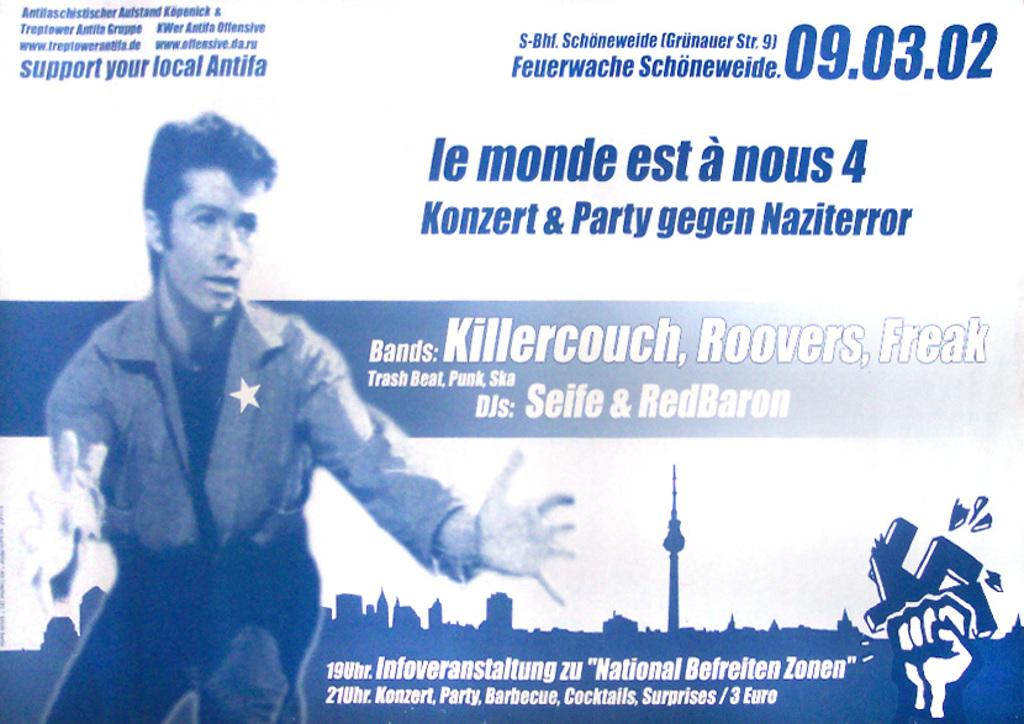What is the main subject of the image? There is a photo of a woman in the image. What can be seen in the background of the image? There are buildings visible in the image. Is there any text or writing on the image? Yes, there is something written on the image. Can you describe any other elements in the image besides the woman and the buildings? There are other unspecified elements in the image. What type of popcorn is being served in the image? There is no popcorn present in the image. What color are the jeans the woman is wearing in the image? The provided facts do not mention the woman's clothing, so we cannot determine the color of her jeans. --- Facts: 1. There is a car in the image. 2. The car is parked on the street. 3. There are trees in the background of the image. 4. The sky is visible in the image. 5. There are other cars parked on the street. Absurd Topics: parrot, sand, volcano Conversation: What is the main subject of the image? There is a car in the image. Where is the car located in the image? The car is parked on the street. What can be seen in the background of the image? There are trees in the background of the image. What is visible above the trees in the image? The sky is visible in the image. Can you describe any other cars in the image? Yes, there are other cars parked on the street. Reasoning: Let's think step by step in order to produce the conversation. We start by identifying the main subject of the image, which is the car. Then, we describe the location of the car, which is parked on the street. Next, we acknowledge the presence of trees and the sky in the background. Finally, we mention that there are other cars parked on the street, providing additional context about the scene. Absurd Question/Answer: What type of parrot is sitting on the car's hood in the image? There is no parrot present on the car's hood in the image. Is there any sand visible in the image? There is no sand visible in the image. 